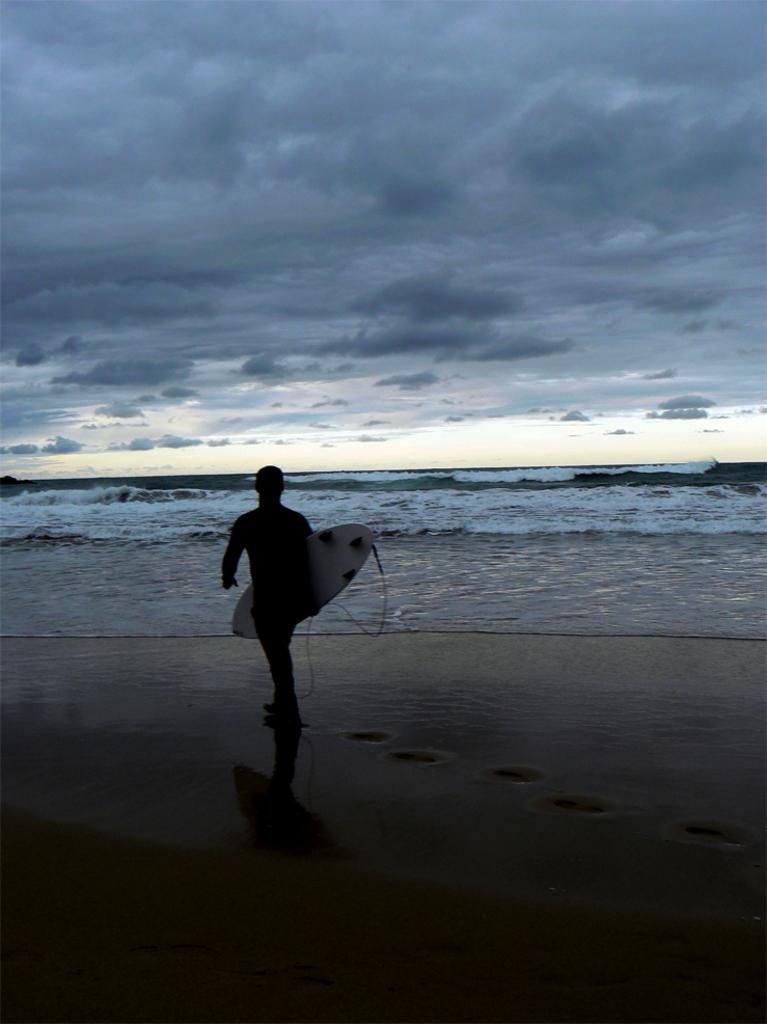What is present in the image? There is a person in the image. What is the person holding? The person is holding something. What can be seen in the background of the image? There is water and clouds in the sky visible in the background of the image. What type of produce is being sold in the image? There is no produce or indication of a sale present in the image. 